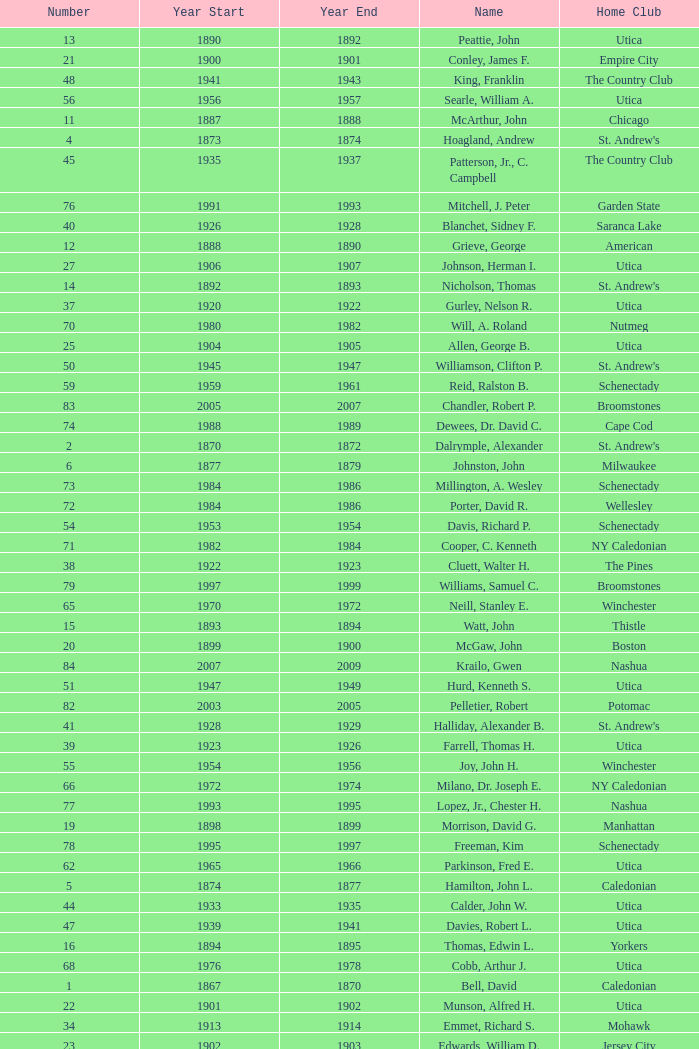Which Number has a Year Start smaller than 1874, and a Year End larger than 1873? 4.0. 